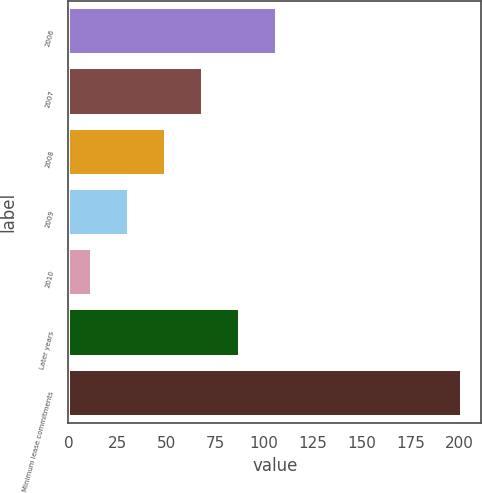Convert chart. <chart><loc_0><loc_0><loc_500><loc_500><bar_chart><fcel>2006<fcel>2007<fcel>2008<fcel>2009<fcel>2010<fcel>Later years<fcel>Minimum lease commitments<nl><fcel>106.5<fcel>68.7<fcel>49.8<fcel>30.9<fcel>12<fcel>87.6<fcel>201<nl></chart> 